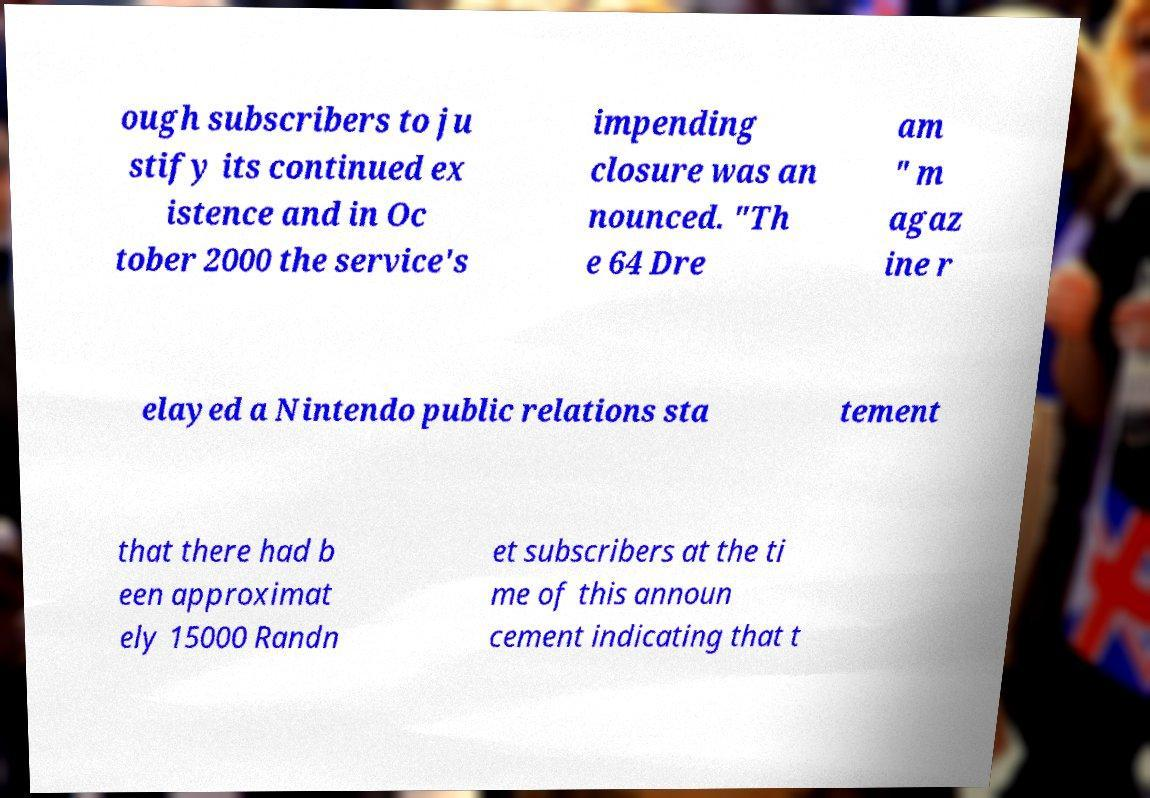There's text embedded in this image that I need extracted. Can you transcribe it verbatim? ough subscribers to ju stify its continued ex istence and in Oc tober 2000 the service's impending closure was an nounced. "Th e 64 Dre am " m agaz ine r elayed a Nintendo public relations sta tement that there had b een approximat ely 15000 Randn et subscribers at the ti me of this announ cement indicating that t 